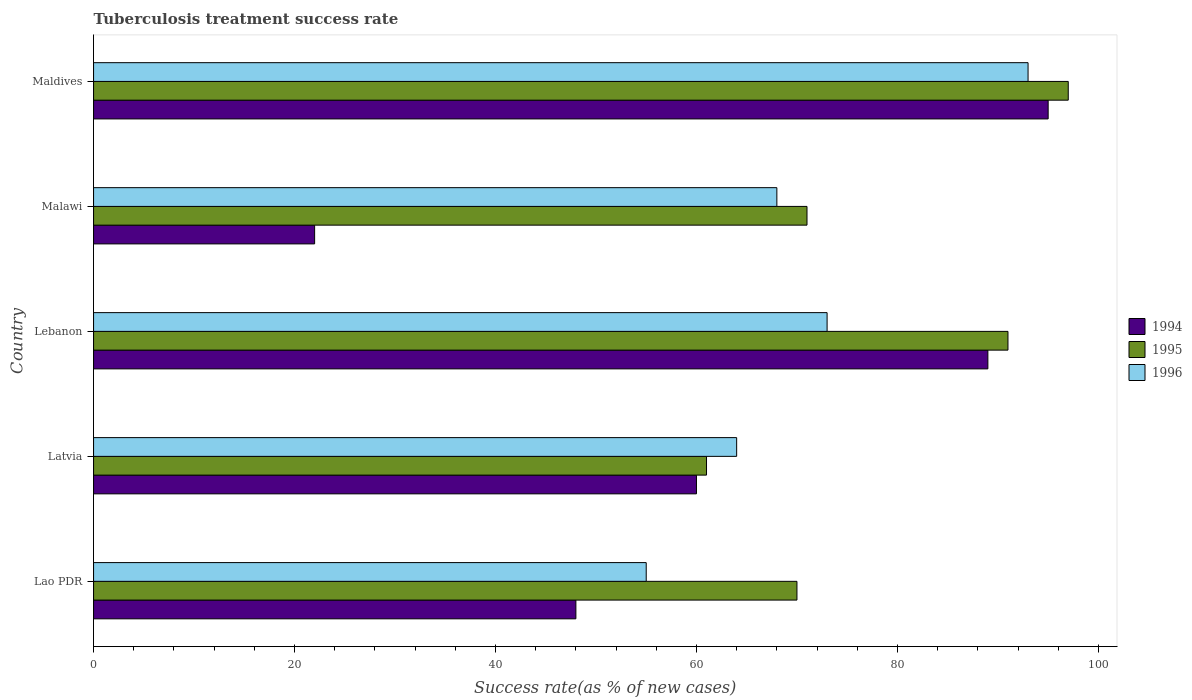How many different coloured bars are there?
Your response must be concise. 3. Are the number of bars on each tick of the Y-axis equal?
Your answer should be compact. Yes. How many bars are there on the 1st tick from the top?
Keep it short and to the point. 3. How many bars are there on the 5th tick from the bottom?
Ensure brevity in your answer.  3. What is the label of the 3rd group of bars from the top?
Your answer should be very brief. Lebanon. In how many cases, is the number of bars for a given country not equal to the number of legend labels?
Your answer should be compact. 0. Across all countries, what is the maximum tuberculosis treatment success rate in 1995?
Ensure brevity in your answer.  97. In which country was the tuberculosis treatment success rate in 1996 maximum?
Give a very brief answer. Maldives. In which country was the tuberculosis treatment success rate in 1995 minimum?
Ensure brevity in your answer.  Latvia. What is the total tuberculosis treatment success rate in 1994 in the graph?
Keep it short and to the point. 314. What is the difference between the tuberculosis treatment success rate in 1996 in Lao PDR and the tuberculosis treatment success rate in 1995 in Lebanon?
Your response must be concise. -36. What is the average tuberculosis treatment success rate in 1996 per country?
Make the answer very short. 70.6. In how many countries, is the tuberculosis treatment success rate in 1995 greater than 40 %?
Your answer should be very brief. 5. What is the ratio of the tuberculosis treatment success rate in 1994 in Lao PDR to that in Latvia?
Your response must be concise. 0.8. Is the tuberculosis treatment success rate in 1994 in Lao PDR less than that in Maldives?
Your response must be concise. Yes. What is the difference between the highest and the second highest tuberculosis treatment success rate in 1996?
Your response must be concise. 20. What is the difference between the highest and the lowest tuberculosis treatment success rate in 1996?
Your response must be concise. 38. In how many countries, is the tuberculosis treatment success rate in 1994 greater than the average tuberculosis treatment success rate in 1994 taken over all countries?
Give a very brief answer. 2. Is the sum of the tuberculosis treatment success rate in 1994 in Latvia and Maldives greater than the maximum tuberculosis treatment success rate in 1996 across all countries?
Make the answer very short. Yes. What does the 3rd bar from the bottom in Maldives represents?
Give a very brief answer. 1996. How many bars are there?
Offer a very short reply. 15. Are all the bars in the graph horizontal?
Provide a short and direct response. Yes. How many countries are there in the graph?
Provide a succinct answer. 5. What is the difference between two consecutive major ticks on the X-axis?
Your response must be concise. 20. Are the values on the major ticks of X-axis written in scientific E-notation?
Keep it short and to the point. No. Does the graph contain any zero values?
Make the answer very short. No. Does the graph contain grids?
Provide a succinct answer. No. Where does the legend appear in the graph?
Provide a short and direct response. Center right. How many legend labels are there?
Your answer should be very brief. 3. What is the title of the graph?
Give a very brief answer. Tuberculosis treatment success rate. What is the label or title of the X-axis?
Keep it short and to the point. Success rate(as % of new cases). What is the label or title of the Y-axis?
Offer a terse response. Country. What is the Success rate(as % of new cases) of 1995 in Lao PDR?
Your answer should be very brief. 70. What is the Success rate(as % of new cases) in 1996 in Lao PDR?
Ensure brevity in your answer.  55. What is the Success rate(as % of new cases) in 1994 in Latvia?
Give a very brief answer. 60. What is the Success rate(as % of new cases) of 1994 in Lebanon?
Provide a short and direct response. 89. What is the Success rate(as % of new cases) of 1995 in Lebanon?
Ensure brevity in your answer.  91. What is the Success rate(as % of new cases) of 1994 in Maldives?
Provide a succinct answer. 95. What is the Success rate(as % of new cases) in 1995 in Maldives?
Make the answer very short. 97. What is the Success rate(as % of new cases) of 1996 in Maldives?
Offer a very short reply. 93. Across all countries, what is the maximum Success rate(as % of new cases) of 1994?
Your answer should be compact. 95. Across all countries, what is the maximum Success rate(as % of new cases) in 1995?
Offer a terse response. 97. Across all countries, what is the maximum Success rate(as % of new cases) in 1996?
Your response must be concise. 93. Across all countries, what is the minimum Success rate(as % of new cases) of 1996?
Offer a terse response. 55. What is the total Success rate(as % of new cases) in 1994 in the graph?
Ensure brevity in your answer.  314. What is the total Success rate(as % of new cases) in 1995 in the graph?
Your answer should be very brief. 390. What is the total Success rate(as % of new cases) in 1996 in the graph?
Provide a succinct answer. 353. What is the difference between the Success rate(as % of new cases) of 1995 in Lao PDR and that in Latvia?
Keep it short and to the point. 9. What is the difference between the Success rate(as % of new cases) of 1994 in Lao PDR and that in Lebanon?
Offer a terse response. -41. What is the difference between the Success rate(as % of new cases) in 1994 in Lao PDR and that in Malawi?
Give a very brief answer. 26. What is the difference between the Success rate(as % of new cases) of 1995 in Lao PDR and that in Malawi?
Provide a succinct answer. -1. What is the difference between the Success rate(as % of new cases) in 1994 in Lao PDR and that in Maldives?
Offer a terse response. -47. What is the difference between the Success rate(as % of new cases) in 1996 in Lao PDR and that in Maldives?
Your response must be concise. -38. What is the difference between the Success rate(as % of new cases) of 1994 in Latvia and that in Malawi?
Your answer should be very brief. 38. What is the difference between the Success rate(as % of new cases) in 1995 in Latvia and that in Malawi?
Give a very brief answer. -10. What is the difference between the Success rate(as % of new cases) in 1996 in Latvia and that in Malawi?
Give a very brief answer. -4. What is the difference between the Success rate(as % of new cases) of 1994 in Latvia and that in Maldives?
Your answer should be very brief. -35. What is the difference between the Success rate(as % of new cases) in 1995 in Latvia and that in Maldives?
Ensure brevity in your answer.  -36. What is the difference between the Success rate(as % of new cases) in 1996 in Latvia and that in Maldives?
Provide a succinct answer. -29. What is the difference between the Success rate(as % of new cases) of 1996 in Lebanon and that in Malawi?
Ensure brevity in your answer.  5. What is the difference between the Success rate(as % of new cases) in 1996 in Lebanon and that in Maldives?
Your answer should be compact. -20. What is the difference between the Success rate(as % of new cases) of 1994 in Malawi and that in Maldives?
Ensure brevity in your answer.  -73. What is the difference between the Success rate(as % of new cases) of 1995 in Malawi and that in Maldives?
Provide a short and direct response. -26. What is the difference between the Success rate(as % of new cases) in 1994 in Lao PDR and the Success rate(as % of new cases) in 1995 in Latvia?
Keep it short and to the point. -13. What is the difference between the Success rate(as % of new cases) of 1994 in Lao PDR and the Success rate(as % of new cases) of 1996 in Latvia?
Offer a very short reply. -16. What is the difference between the Success rate(as % of new cases) in 1995 in Lao PDR and the Success rate(as % of new cases) in 1996 in Latvia?
Give a very brief answer. 6. What is the difference between the Success rate(as % of new cases) of 1994 in Lao PDR and the Success rate(as % of new cases) of 1995 in Lebanon?
Provide a short and direct response. -43. What is the difference between the Success rate(as % of new cases) of 1994 in Lao PDR and the Success rate(as % of new cases) of 1996 in Lebanon?
Provide a short and direct response. -25. What is the difference between the Success rate(as % of new cases) of 1994 in Lao PDR and the Success rate(as % of new cases) of 1995 in Malawi?
Keep it short and to the point. -23. What is the difference between the Success rate(as % of new cases) of 1994 in Lao PDR and the Success rate(as % of new cases) of 1996 in Malawi?
Your response must be concise. -20. What is the difference between the Success rate(as % of new cases) of 1995 in Lao PDR and the Success rate(as % of new cases) of 1996 in Malawi?
Offer a very short reply. 2. What is the difference between the Success rate(as % of new cases) of 1994 in Lao PDR and the Success rate(as % of new cases) of 1995 in Maldives?
Offer a terse response. -49. What is the difference between the Success rate(as % of new cases) in 1994 in Lao PDR and the Success rate(as % of new cases) in 1996 in Maldives?
Make the answer very short. -45. What is the difference between the Success rate(as % of new cases) of 1995 in Lao PDR and the Success rate(as % of new cases) of 1996 in Maldives?
Provide a succinct answer. -23. What is the difference between the Success rate(as % of new cases) in 1994 in Latvia and the Success rate(as % of new cases) in 1995 in Lebanon?
Your response must be concise. -31. What is the difference between the Success rate(as % of new cases) of 1994 in Latvia and the Success rate(as % of new cases) of 1996 in Malawi?
Offer a terse response. -8. What is the difference between the Success rate(as % of new cases) of 1994 in Latvia and the Success rate(as % of new cases) of 1995 in Maldives?
Offer a very short reply. -37. What is the difference between the Success rate(as % of new cases) in 1994 in Latvia and the Success rate(as % of new cases) in 1996 in Maldives?
Your answer should be very brief. -33. What is the difference between the Success rate(as % of new cases) in 1995 in Latvia and the Success rate(as % of new cases) in 1996 in Maldives?
Offer a terse response. -32. What is the difference between the Success rate(as % of new cases) in 1994 in Lebanon and the Success rate(as % of new cases) in 1995 in Malawi?
Your answer should be very brief. 18. What is the difference between the Success rate(as % of new cases) of 1994 in Malawi and the Success rate(as % of new cases) of 1995 in Maldives?
Make the answer very short. -75. What is the difference between the Success rate(as % of new cases) of 1994 in Malawi and the Success rate(as % of new cases) of 1996 in Maldives?
Give a very brief answer. -71. What is the average Success rate(as % of new cases) in 1994 per country?
Your answer should be compact. 62.8. What is the average Success rate(as % of new cases) of 1995 per country?
Your response must be concise. 78. What is the average Success rate(as % of new cases) of 1996 per country?
Offer a very short reply. 70.6. What is the difference between the Success rate(as % of new cases) in 1994 and Success rate(as % of new cases) in 1995 in Lao PDR?
Ensure brevity in your answer.  -22. What is the difference between the Success rate(as % of new cases) in 1994 and Success rate(as % of new cases) in 1996 in Lao PDR?
Your response must be concise. -7. What is the difference between the Success rate(as % of new cases) in 1994 and Success rate(as % of new cases) in 1996 in Lebanon?
Your response must be concise. 16. What is the difference between the Success rate(as % of new cases) of 1994 and Success rate(as % of new cases) of 1995 in Malawi?
Ensure brevity in your answer.  -49. What is the difference between the Success rate(as % of new cases) of 1994 and Success rate(as % of new cases) of 1996 in Malawi?
Offer a terse response. -46. What is the difference between the Success rate(as % of new cases) of 1995 and Success rate(as % of new cases) of 1996 in Maldives?
Your answer should be very brief. 4. What is the ratio of the Success rate(as % of new cases) of 1995 in Lao PDR to that in Latvia?
Offer a terse response. 1.15. What is the ratio of the Success rate(as % of new cases) in 1996 in Lao PDR to that in Latvia?
Make the answer very short. 0.86. What is the ratio of the Success rate(as % of new cases) of 1994 in Lao PDR to that in Lebanon?
Offer a terse response. 0.54. What is the ratio of the Success rate(as % of new cases) of 1995 in Lao PDR to that in Lebanon?
Provide a succinct answer. 0.77. What is the ratio of the Success rate(as % of new cases) of 1996 in Lao PDR to that in Lebanon?
Provide a succinct answer. 0.75. What is the ratio of the Success rate(as % of new cases) in 1994 in Lao PDR to that in Malawi?
Offer a terse response. 2.18. What is the ratio of the Success rate(as % of new cases) of 1995 in Lao PDR to that in Malawi?
Offer a very short reply. 0.99. What is the ratio of the Success rate(as % of new cases) in 1996 in Lao PDR to that in Malawi?
Your answer should be compact. 0.81. What is the ratio of the Success rate(as % of new cases) of 1994 in Lao PDR to that in Maldives?
Your response must be concise. 0.51. What is the ratio of the Success rate(as % of new cases) of 1995 in Lao PDR to that in Maldives?
Your answer should be very brief. 0.72. What is the ratio of the Success rate(as % of new cases) of 1996 in Lao PDR to that in Maldives?
Ensure brevity in your answer.  0.59. What is the ratio of the Success rate(as % of new cases) of 1994 in Latvia to that in Lebanon?
Make the answer very short. 0.67. What is the ratio of the Success rate(as % of new cases) in 1995 in Latvia to that in Lebanon?
Your answer should be compact. 0.67. What is the ratio of the Success rate(as % of new cases) in 1996 in Latvia to that in Lebanon?
Make the answer very short. 0.88. What is the ratio of the Success rate(as % of new cases) in 1994 in Latvia to that in Malawi?
Offer a terse response. 2.73. What is the ratio of the Success rate(as % of new cases) of 1995 in Latvia to that in Malawi?
Your response must be concise. 0.86. What is the ratio of the Success rate(as % of new cases) in 1994 in Latvia to that in Maldives?
Provide a short and direct response. 0.63. What is the ratio of the Success rate(as % of new cases) of 1995 in Latvia to that in Maldives?
Provide a short and direct response. 0.63. What is the ratio of the Success rate(as % of new cases) in 1996 in Latvia to that in Maldives?
Your answer should be very brief. 0.69. What is the ratio of the Success rate(as % of new cases) of 1994 in Lebanon to that in Malawi?
Your answer should be compact. 4.05. What is the ratio of the Success rate(as % of new cases) in 1995 in Lebanon to that in Malawi?
Your response must be concise. 1.28. What is the ratio of the Success rate(as % of new cases) of 1996 in Lebanon to that in Malawi?
Provide a short and direct response. 1.07. What is the ratio of the Success rate(as % of new cases) of 1994 in Lebanon to that in Maldives?
Keep it short and to the point. 0.94. What is the ratio of the Success rate(as % of new cases) in 1995 in Lebanon to that in Maldives?
Your response must be concise. 0.94. What is the ratio of the Success rate(as % of new cases) of 1996 in Lebanon to that in Maldives?
Make the answer very short. 0.78. What is the ratio of the Success rate(as % of new cases) of 1994 in Malawi to that in Maldives?
Give a very brief answer. 0.23. What is the ratio of the Success rate(as % of new cases) of 1995 in Malawi to that in Maldives?
Offer a very short reply. 0.73. What is the ratio of the Success rate(as % of new cases) in 1996 in Malawi to that in Maldives?
Offer a terse response. 0.73. What is the difference between the highest and the second highest Success rate(as % of new cases) in 1994?
Provide a succinct answer. 6. What is the difference between the highest and the second highest Success rate(as % of new cases) of 1995?
Your answer should be very brief. 6. What is the difference between the highest and the second highest Success rate(as % of new cases) of 1996?
Your answer should be very brief. 20. What is the difference between the highest and the lowest Success rate(as % of new cases) in 1994?
Provide a succinct answer. 73. 